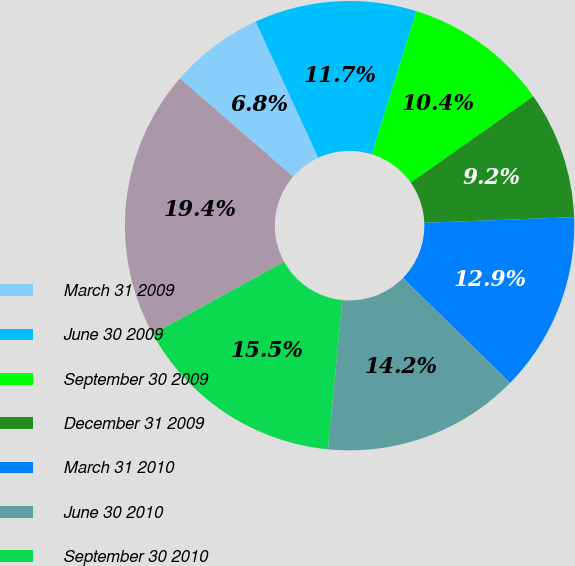Convert chart. <chart><loc_0><loc_0><loc_500><loc_500><pie_chart><fcel>March 31 2009<fcel>June 30 2009<fcel>September 30 2009<fcel>December 31 2009<fcel>March 31 2010<fcel>June 30 2010<fcel>September 30 2010<fcel>December 31 2010<nl><fcel>6.76%<fcel>11.68%<fcel>10.42%<fcel>9.16%<fcel>12.94%<fcel>14.2%<fcel>15.46%<fcel>19.37%<nl></chart> 